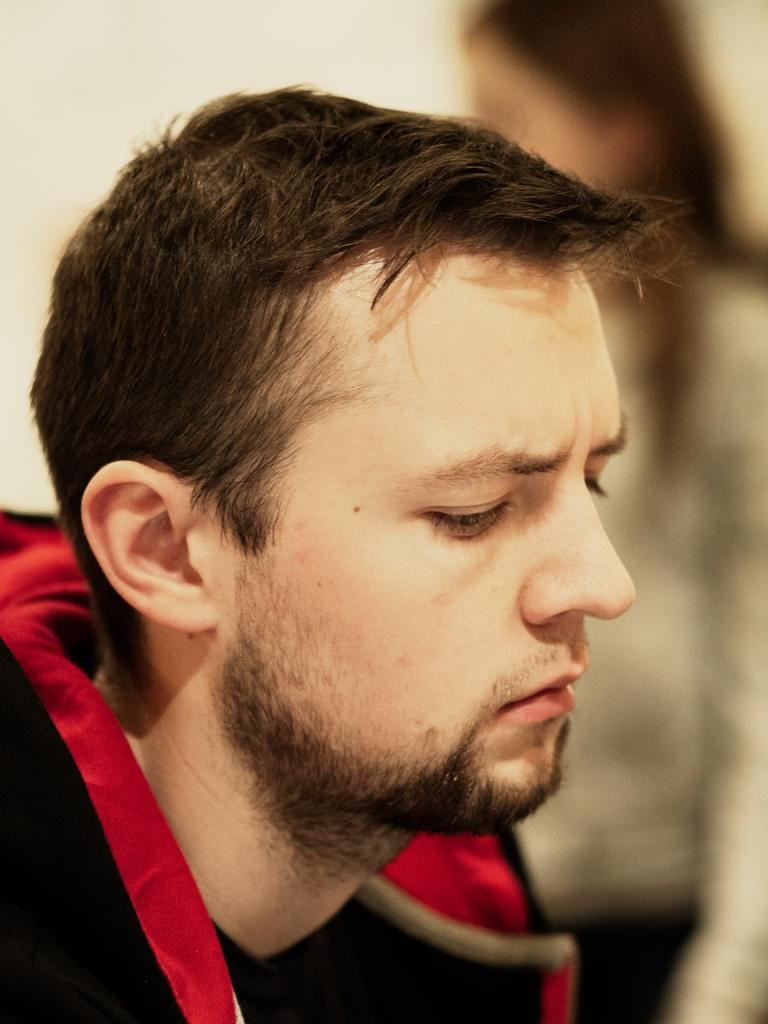Who is the main subject in the image? There is a man in the image. What is the man wearing? The man is wearing a red and black jacket. Can you describe the background of the image? The background of the image is blurred. Are there any other people visible in the image? Yes, there is a person visible in the background. What type of circle is being used as a table in the image? There is no circle or table present in the image. 